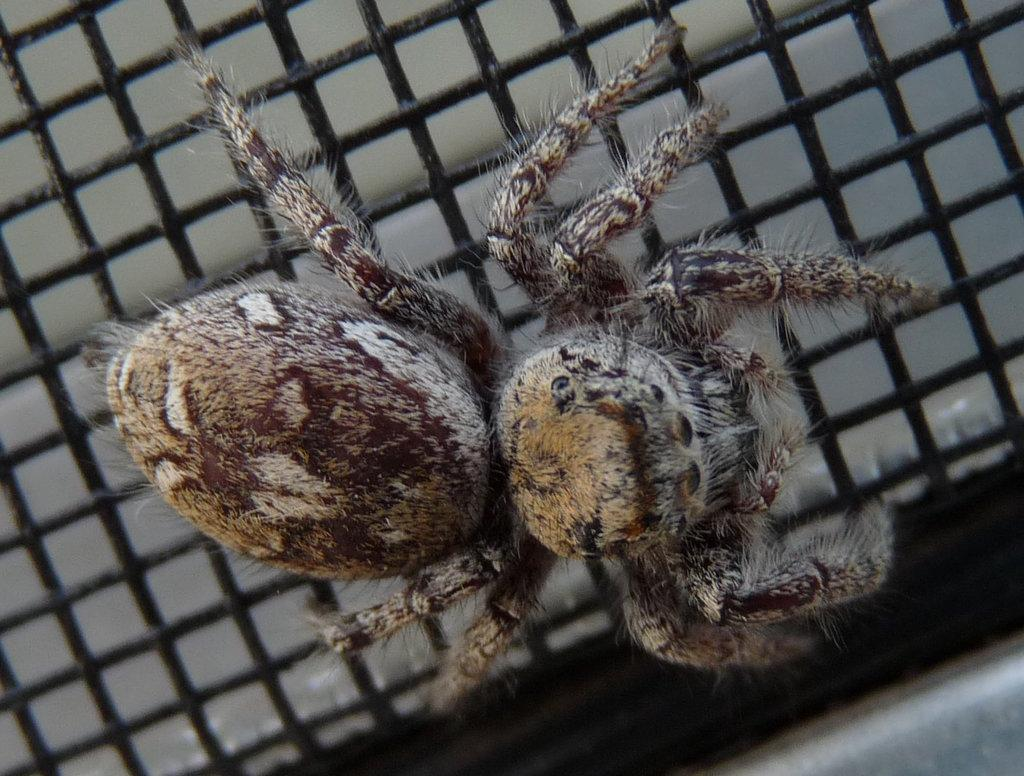What is the main subject of the image? The main subject of the image is a spider. Where is the spider located in the image? The spider is on a black color grill. What type of insect can be seen playing with a yoke in the image? There is no insect playing with a yoke present in the image; it only features a spider on a black color grill. 